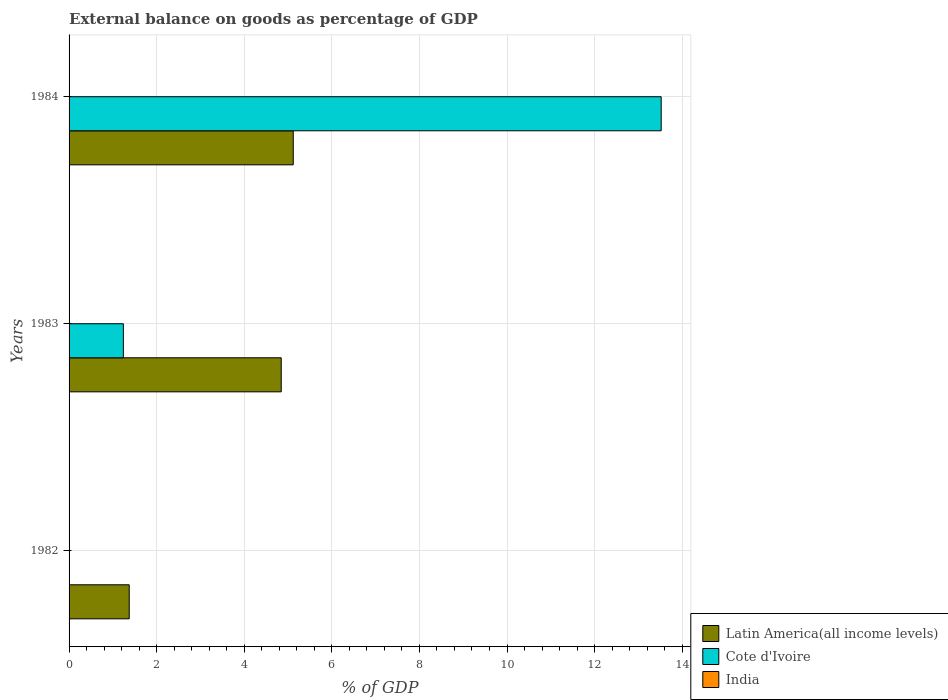How many bars are there on the 3rd tick from the top?
Provide a short and direct response. 1. How many bars are there on the 2nd tick from the bottom?
Offer a terse response. 2. What is the external balance on goods as percentage of GDP in India in 1984?
Make the answer very short. 0. Across all years, what is the maximum external balance on goods as percentage of GDP in Cote d'Ivoire?
Your answer should be compact. 13.52. Across all years, what is the minimum external balance on goods as percentage of GDP in Latin America(all income levels)?
Offer a terse response. 1.37. What is the total external balance on goods as percentage of GDP in Cote d'Ivoire in the graph?
Offer a terse response. 14.76. What is the difference between the external balance on goods as percentage of GDP in Latin America(all income levels) in 1982 and that in 1983?
Make the answer very short. -3.47. What is the difference between the external balance on goods as percentage of GDP in India in 1982 and the external balance on goods as percentage of GDP in Cote d'Ivoire in 1984?
Your response must be concise. -13.52. What is the average external balance on goods as percentage of GDP in Latin America(all income levels) per year?
Offer a very short reply. 3.78. In the year 1984, what is the difference between the external balance on goods as percentage of GDP in Latin America(all income levels) and external balance on goods as percentage of GDP in Cote d'Ivoire?
Keep it short and to the point. -8.4. In how many years, is the external balance on goods as percentage of GDP in India greater than 10.4 %?
Ensure brevity in your answer.  0. What is the ratio of the external balance on goods as percentage of GDP in Latin America(all income levels) in 1983 to that in 1984?
Offer a terse response. 0.95. Is the external balance on goods as percentage of GDP in Latin America(all income levels) in 1982 less than that in 1984?
Ensure brevity in your answer.  Yes. What is the difference between the highest and the lowest external balance on goods as percentage of GDP in Latin America(all income levels)?
Provide a succinct answer. 3.75. Is the sum of the external balance on goods as percentage of GDP in Latin America(all income levels) in 1982 and 1984 greater than the maximum external balance on goods as percentage of GDP in Cote d'Ivoire across all years?
Your response must be concise. No. Is it the case that in every year, the sum of the external balance on goods as percentage of GDP in India and external balance on goods as percentage of GDP in Cote d'Ivoire is greater than the external balance on goods as percentage of GDP in Latin America(all income levels)?
Your answer should be very brief. No. Are all the bars in the graph horizontal?
Make the answer very short. Yes. How many years are there in the graph?
Offer a very short reply. 3. Are the values on the major ticks of X-axis written in scientific E-notation?
Provide a short and direct response. No. Where does the legend appear in the graph?
Ensure brevity in your answer.  Bottom right. How many legend labels are there?
Make the answer very short. 3. What is the title of the graph?
Keep it short and to the point. External balance on goods as percentage of GDP. What is the label or title of the X-axis?
Offer a very short reply. % of GDP. What is the % of GDP of Latin America(all income levels) in 1982?
Provide a short and direct response. 1.37. What is the % of GDP in Latin America(all income levels) in 1983?
Your answer should be very brief. 4.84. What is the % of GDP of Cote d'Ivoire in 1983?
Provide a succinct answer. 1.24. What is the % of GDP of Latin America(all income levels) in 1984?
Your answer should be very brief. 5.12. What is the % of GDP in Cote d'Ivoire in 1984?
Keep it short and to the point. 13.52. Across all years, what is the maximum % of GDP of Latin America(all income levels)?
Give a very brief answer. 5.12. Across all years, what is the maximum % of GDP in Cote d'Ivoire?
Offer a terse response. 13.52. Across all years, what is the minimum % of GDP in Latin America(all income levels)?
Your answer should be very brief. 1.37. What is the total % of GDP of Latin America(all income levels) in the graph?
Provide a short and direct response. 11.34. What is the total % of GDP in Cote d'Ivoire in the graph?
Your answer should be compact. 14.76. What is the total % of GDP in India in the graph?
Ensure brevity in your answer.  0. What is the difference between the % of GDP of Latin America(all income levels) in 1982 and that in 1983?
Keep it short and to the point. -3.47. What is the difference between the % of GDP in Latin America(all income levels) in 1982 and that in 1984?
Your answer should be very brief. -3.75. What is the difference between the % of GDP of Latin America(all income levels) in 1983 and that in 1984?
Provide a short and direct response. -0.27. What is the difference between the % of GDP of Cote d'Ivoire in 1983 and that in 1984?
Make the answer very short. -12.28. What is the difference between the % of GDP of Latin America(all income levels) in 1982 and the % of GDP of Cote d'Ivoire in 1983?
Provide a short and direct response. 0.13. What is the difference between the % of GDP of Latin America(all income levels) in 1982 and the % of GDP of Cote d'Ivoire in 1984?
Give a very brief answer. -12.15. What is the difference between the % of GDP of Latin America(all income levels) in 1983 and the % of GDP of Cote d'Ivoire in 1984?
Your response must be concise. -8.68. What is the average % of GDP in Latin America(all income levels) per year?
Offer a very short reply. 3.78. What is the average % of GDP in Cote d'Ivoire per year?
Make the answer very short. 4.92. In the year 1983, what is the difference between the % of GDP in Latin America(all income levels) and % of GDP in Cote d'Ivoire?
Ensure brevity in your answer.  3.61. In the year 1984, what is the difference between the % of GDP of Latin America(all income levels) and % of GDP of Cote d'Ivoire?
Make the answer very short. -8.4. What is the ratio of the % of GDP of Latin America(all income levels) in 1982 to that in 1983?
Your answer should be compact. 0.28. What is the ratio of the % of GDP in Latin America(all income levels) in 1982 to that in 1984?
Give a very brief answer. 0.27. What is the ratio of the % of GDP of Latin America(all income levels) in 1983 to that in 1984?
Give a very brief answer. 0.95. What is the ratio of the % of GDP in Cote d'Ivoire in 1983 to that in 1984?
Keep it short and to the point. 0.09. What is the difference between the highest and the second highest % of GDP in Latin America(all income levels)?
Provide a succinct answer. 0.27. What is the difference between the highest and the lowest % of GDP of Latin America(all income levels)?
Offer a very short reply. 3.75. What is the difference between the highest and the lowest % of GDP in Cote d'Ivoire?
Offer a very short reply. 13.52. 